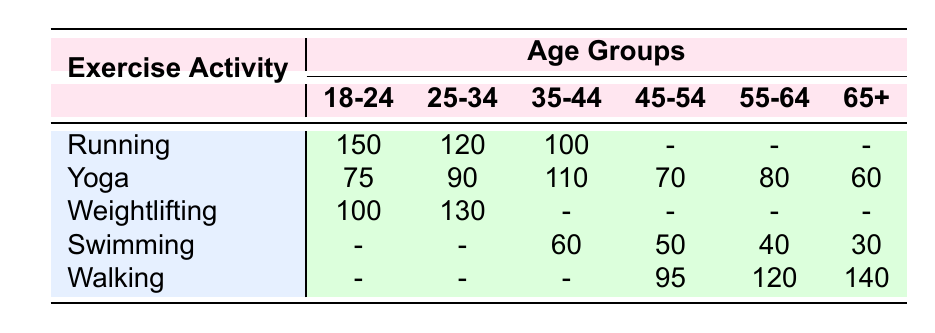What is the frequency of Running for the age group 25-34? The table shows that the frequency of Running in the 25-34 age group is 120, which can be directly found in the corresponding cell of the table.
Answer: 120 Which exercise activity has the highest frequency among the 18-24 age group? The frequencies for the 18-24 age group are: Running (150), Yoga (75), and Weightlifting (100). The highest frequency among these values is Running with 150.
Answer: Running Is there any frequency recorded for Weightlifting in the age group 65+? In the table, there is no frequency recorded for Weightlifting in the 65+ age group; the cell for Weightlifting under that age group is empty (represented with a dash).
Answer: No What is the total frequency of Swimming across all age groups? The frequencies for Swimming in each age group are 60 (35-44), 50 (45-54), 40 (55-64), and 30 (65+). Summing these up gives 60 + 50 + 40 + 30 = 180.
Answer: 180 Which age group has the highest frequency of Walking activities, and what is that frequency? The table lists frequencies for Walking as follows: 95 (45-54), 120 (55-64), and 140 (65+). The highest frequency is 140 in the 65+ age group.
Answer: 65+ age group, frequency 140 How many total individuals prefer Yoga between the ages of 35 and 54? The frequencies for Yoga in these age groups are 110 (35-44) and 70 (45-54). Adding these two gives 110 + 70 = 180.
Answer: 180 Is Yoga more popular than Running in the age group 35-44? The frequency of Running in the 35-44 age group is 100, while the frequency of Yoga is 110. Since 110 is greater than 100, Yoga is indeed more popular.
Answer: Yes What can be concluded about the popularity of Weightlifting among ages 45-54 and 55-64? The table indicates that there is no recorded frequency for Weightlifting in both the 45-54 and 55-64 age groups, which suggests it is not a popular choice among these ages.
Answer: Weightlifting is not popular in these age groups 